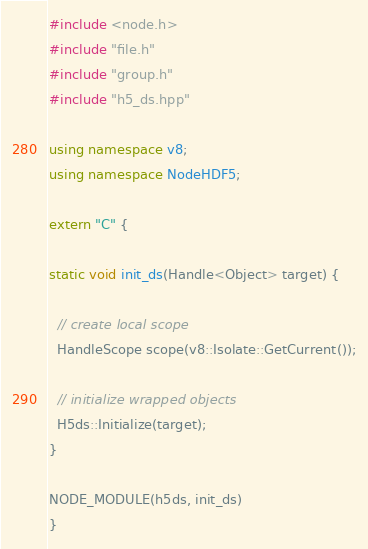Convert code to text. <code><loc_0><loc_0><loc_500><loc_500><_C++_>#include <node.h>
#include "file.h"
#include "group.h"
#include "h5_ds.hpp"

using namespace v8;
using namespace NodeHDF5;

extern "C" {

static void init_ds(Handle<Object> target) {

  // create local scope
  HandleScope scope(v8::Isolate::GetCurrent());

  // initialize wrapped objects
  H5ds::Initialize(target);
}

NODE_MODULE(h5ds, init_ds)
}</code> 